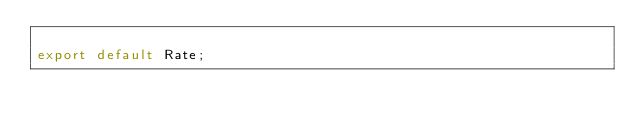Convert code to text. <code><loc_0><loc_0><loc_500><loc_500><_TypeScript_>
export default Rate;
</code> 